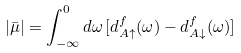Convert formula to latex. <formula><loc_0><loc_0><loc_500><loc_500>| \bar { \mu } | = \int _ { - \infty } ^ { 0 } d \omega \, [ d _ { A \uparrow } ^ { f } ( \omega ) - d _ { A \downarrow } ^ { f } ( \omega ) ]</formula> 